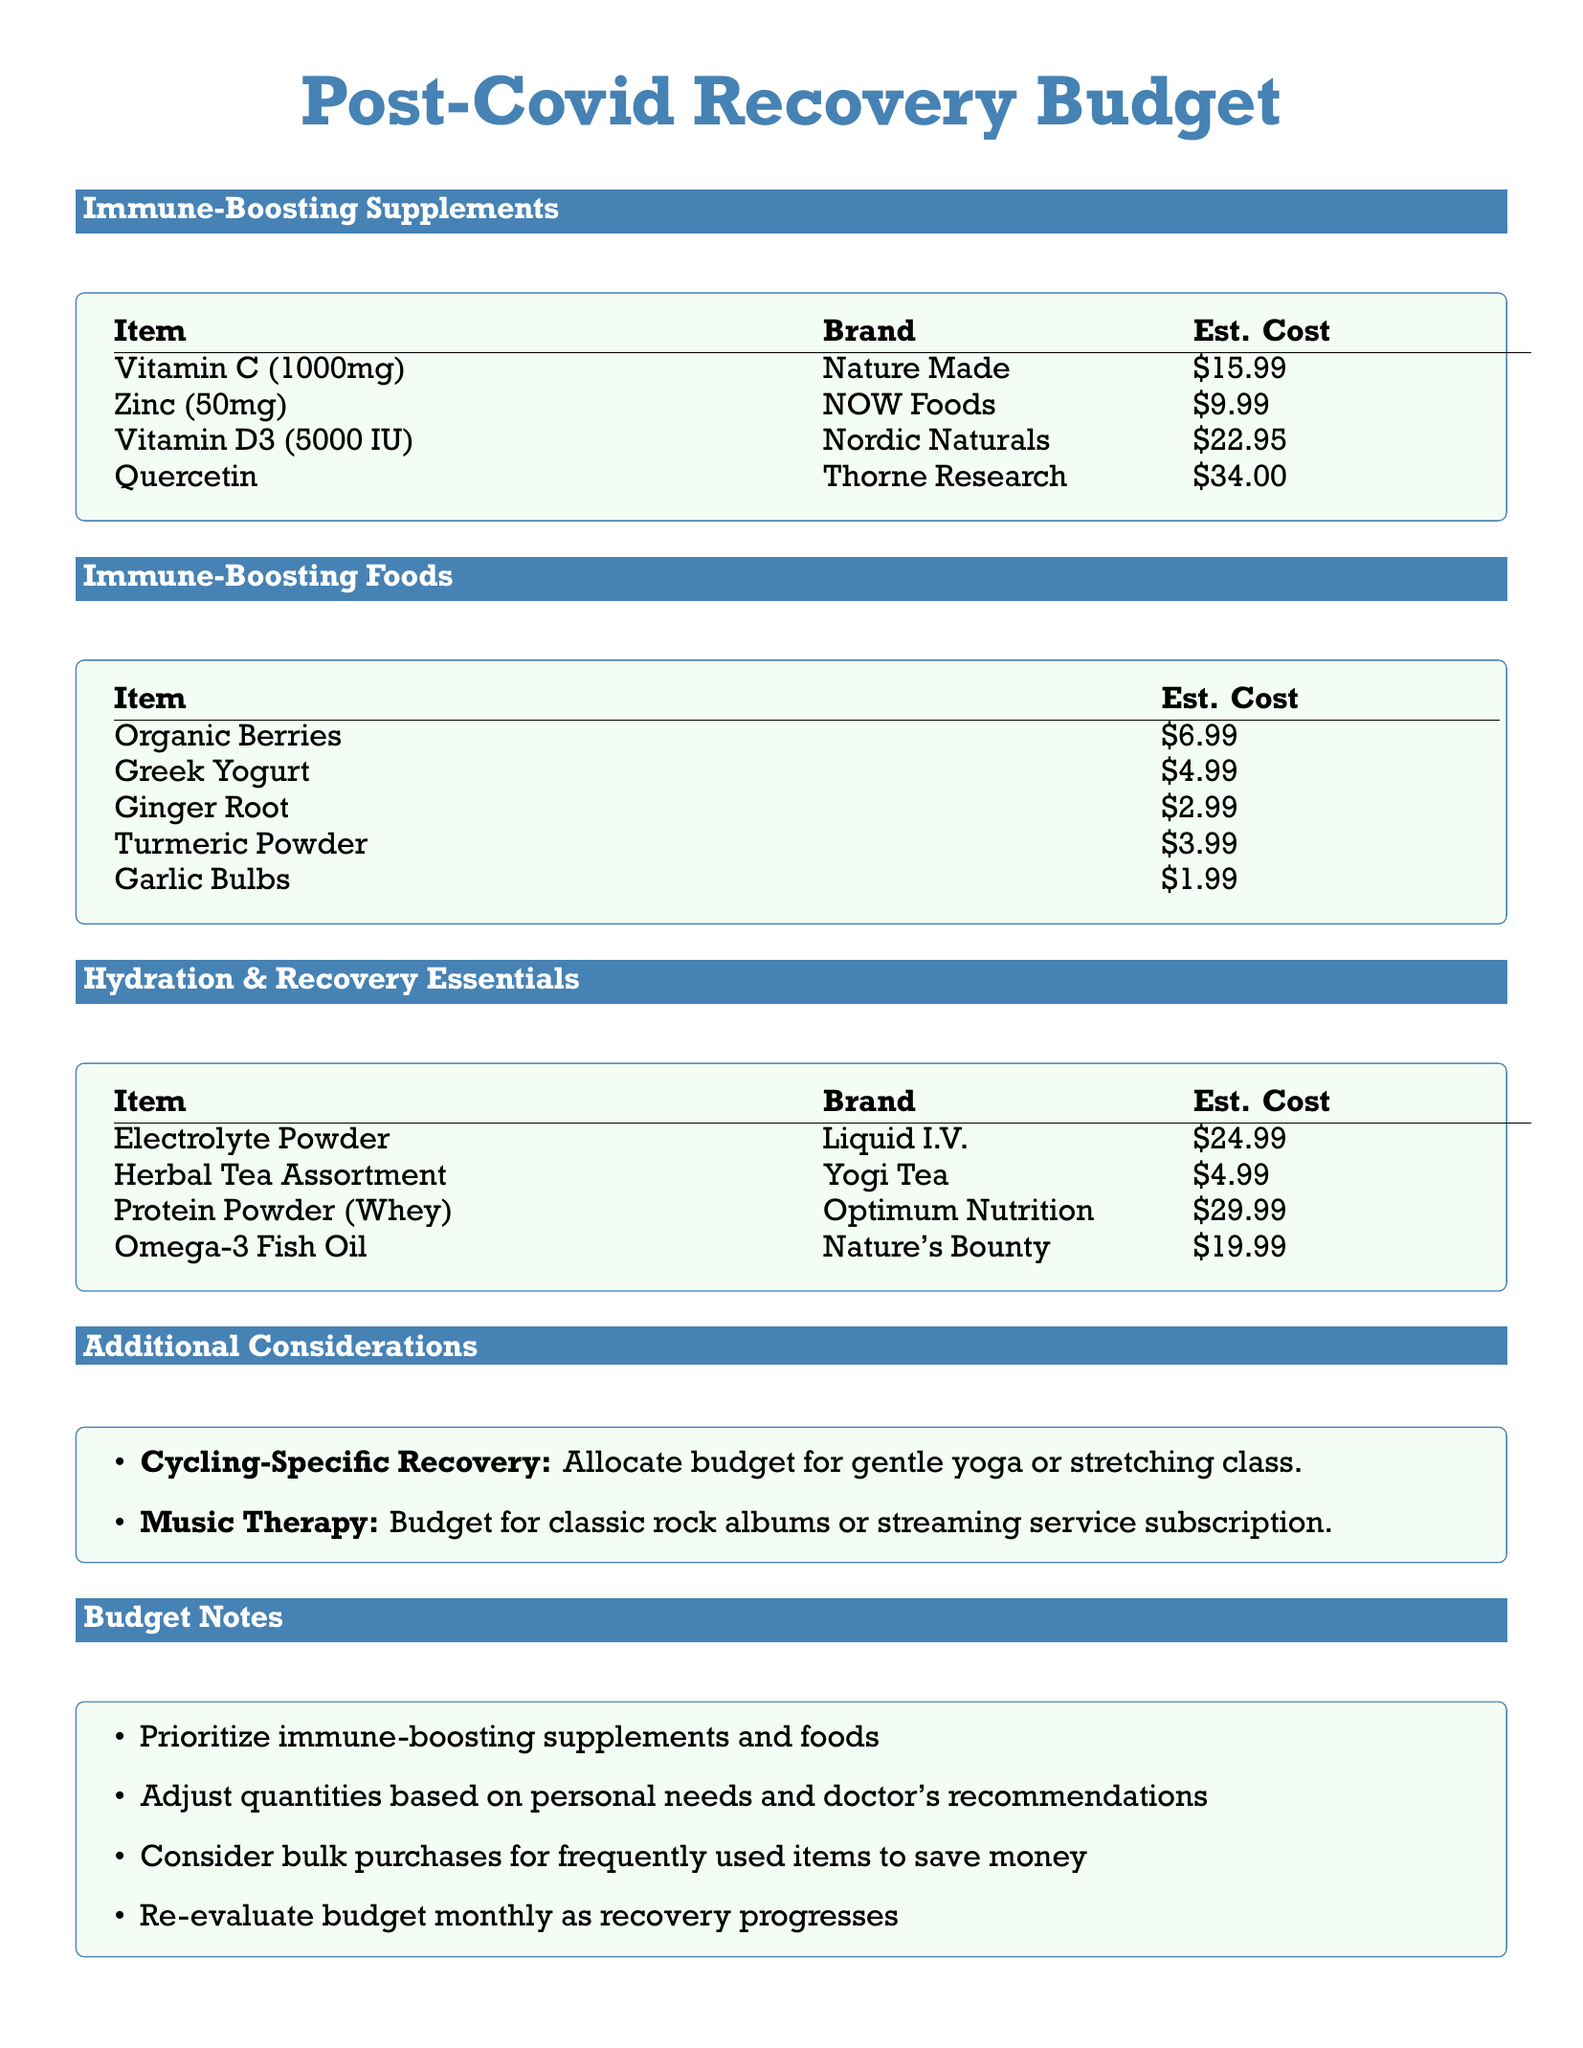What is the estimated cost of Vitamin D3? Vitamin D3 is listed in the document with an estimated cost of $22.95.
Answer: $22.95 Which brand offers Quercetin? The document specifies that Quercetin is provided by Thorne Research.
Answer: Thorne Research How much does Greek Yogurt cost? The cost for Greek Yogurt is explicitly mentioned as $4.99 in the budget.
Answer: $4.99 What is the total estimated cost of all immune-boosting supplements? The total can be calculated as the sum of individual costs: $15.99 + $9.99 + $22.95 + $34.00 = $82.93.
Answer: $82.93 Which food item is priced the lowest? The lowest priced item listed under immune-boosting foods is Garlic Bulbs at $1.99.
Answer: Garlic Bulbs What is suggested to allocate for cycling-specific recovery? The document suggests to allocate budget for gentle yoga or stretching class.
Answer: Gentle yoga or stretching class How often should the budget be re-evaluated? The document notes that the budget should be re-evaluated monthly as recovery progresses.
Answer: Monthly Which supplement brand is mentioned for Omega-3 Fish Oil? The document lists Nature's Bounty as the brand for Omega-3 Fish Oil.
Answer: Nature's Bounty What is the overall focus of the budget notes section? The budget notes section emphasizes prioritizing immune-boosting supplements and foods.
Answer: Prioritize immune-boosting supplements and foods 